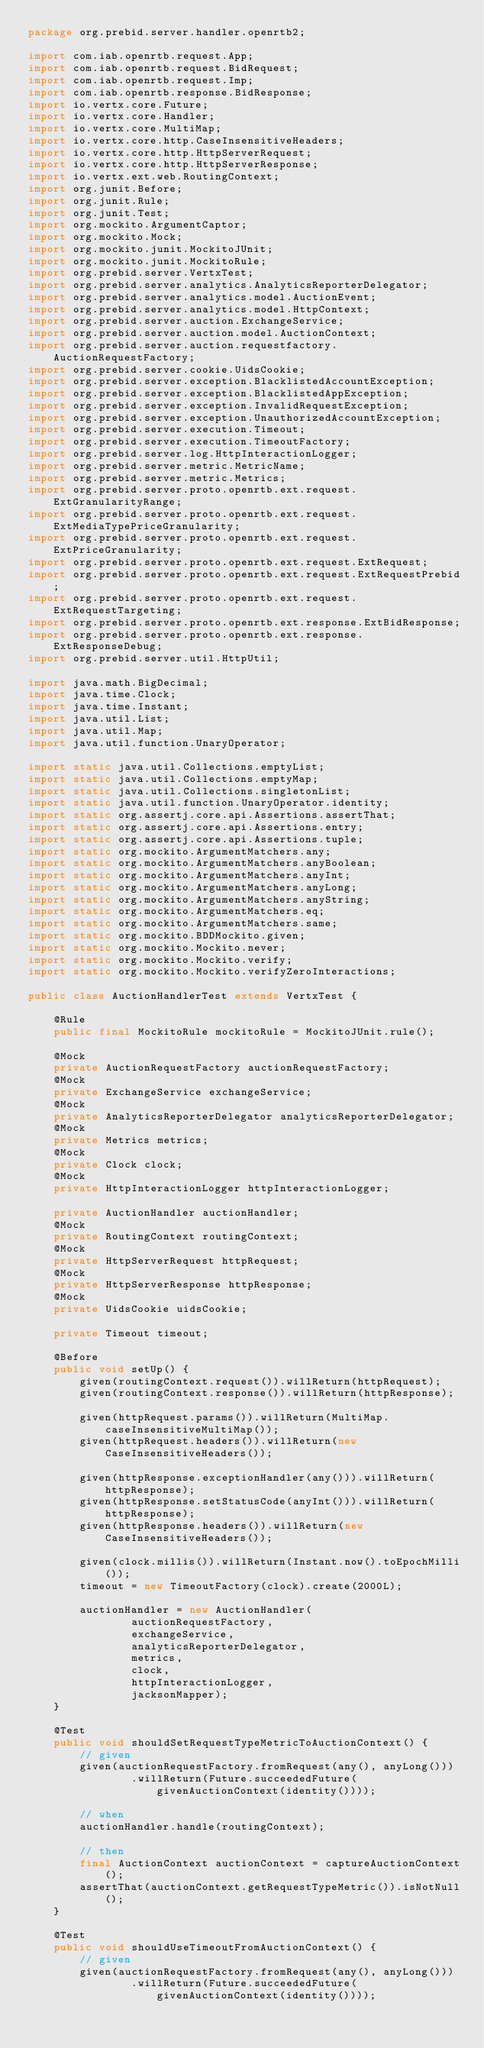Convert code to text. <code><loc_0><loc_0><loc_500><loc_500><_Java_>package org.prebid.server.handler.openrtb2;

import com.iab.openrtb.request.App;
import com.iab.openrtb.request.BidRequest;
import com.iab.openrtb.request.Imp;
import com.iab.openrtb.response.BidResponse;
import io.vertx.core.Future;
import io.vertx.core.Handler;
import io.vertx.core.MultiMap;
import io.vertx.core.http.CaseInsensitiveHeaders;
import io.vertx.core.http.HttpServerRequest;
import io.vertx.core.http.HttpServerResponse;
import io.vertx.ext.web.RoutingContext;
import org.junit.Before;
import org.junit.Rule;
import org.junit.Test;
import org.mockito.ArgumentCaptor;
import org.mockito.Mock;
import org.mockito.junit.MockitoJUnit;
import org.mockito.junit.MockitoRule;
import org.prebid.server.VertxTest;
import org.prebid.server.analytics.AnalyticsReporterDelegator;
import org.prebid.server.analytics.model.AuctionEvent;
import org.prebid.server.analytics.model.HttpContext;
import org.prebid.server.auction.ExchangeService;
import org.prebid.server.auction.model.AuctionContext;
import org.prebid.server.auction.requestfactory.AuctionRequestFactory;
import org.prebid.server.cookie.UidsCookie;
import org.prebid.server.exception.BlacklistedAccountException;
import org.prebid.server.exception.BlacklistedAppException;
import org.prebid.server.exception.InvalidRequestException;
import org.prebid.server.exception.UnauthorizedAccountException;
import org.prebid.server.execution.Timeout;
import org.prebid.server.execution.TimeoutFactory;
import org.prebid.server.log.HttpInteractionLogger;
import org.prebid.server.metric.MetricName;
import org.prebid.server.metric.Metrics;
import org.prebid.server.proto.openrtb.ext.request.ExtGranularityRange;
import org.prebid.server.proto.openrtb.ext.request.ExtMediaTypePriceGranularity;
import org.prebid.server.proto.openrtb.ext.request.ExtPriceGranularity;
import org.prebid.server.proto.openrtb.ext.request.ExtRequest;
import org.prebid.server.proto.openrtb.ext.request.ExtRequestPrebid;
import org.prebid.server.proto.openrtb.ext.request.ExtRequestTargeting;
import org.prebid.server.proto.openrtb.ext.response.ExtBidResponse;
import org.prebid.server.proto.openrtb.ext.response.ExtResponseDebug;
import org.prebid.server.util.HttpUtil;

import java.math.BigDecimal;
import java.time.Clock;
import java.time.Instant;
import java.util.List;
import java.util.Map;
import java.util.function.UnaryOperator;

import static java.util.Collections.emptyList;
import static java.util.Collections.emptyMap;
import static java.util.Collections.singletonList;
import static java.util.function.UnaryOperator.identity;
import static org.assertj.core.api.Assertions.assertThat;
import static org.assertj.core.api.Assertions.entry;
import static org.assertj.core.api.Assertions.tuple;
import static org.mockito.ArgumentMatchers.any;
import static org.mockito.ArgumentMatchers.anyBoolean;
import static org.mockito.ArgumentMatchers.anyInt;
import static org.mockito.ArgumentMatchers.anyLong;
import static org.mockito.ArgumentMatchers.anyString;
import static org.mockito.ArgumentMatchers.eq;
import static org.mockito.ArgumentMatchers.same;
import static org.mockito.BDDMockito.given;
import static org.mockito.Mockito.never;
import static org.mockito.Mockito.verify;
import static org.mockito.Mockito.verifyZeroInteractions;

public class AuctionHandlerTest extends VertxTest {

    @Rule
    public final MockitoRule mockitoRule = MockitoJUnit.rule();

    @Mock
    private AuctionRequestFactory auctionRequestFactory;
    @Mock
    private ExchangeService exchangeService;
    @Mock
    private AnalyticsReporterDelegator analyticsReporterDelegator;
    @Mock
    private Metrics metrics;
    @Mock
    private Clock clock;
    @Mock
    private HttpInteractionLogger httpInteractionLogger;

    private AuctionHandler auctionHandler;
    @Mock
    private RoutingContext routingContext;
    @Mock
    private HttpServerRequest httpRequest;
    @Mock
    private HttpServerResponse httpResponse;
    @Mock
    private UidsCookie uidsCookie;

    private Timeout timeout;

    @Before
    public void setUp() {
        given(routingContext.request()).willReturn(httpRequest);
        given(routingContext.response()).willReturn(httpResponse);

        given(httpRequest.params()).willReturn(MultiMap.caseInsensitiveMultiMap());
        given(httpRequest.headers()).willReturn(new CaseInsensitiveHeaders());

        given(httpResponse.exceptionHandler(any())).willReturn(httpResponse);
        given(httpResponse.setStatusCode(anyInt())).willReturn(httpResponse);
        given(httpResponse.headers()).willReturn(new CaseInsensitiveHeaders());

        given(clock.millis()).willReturn(Instant.now().toEpochMilli());
        timeout = new TimeoutFactory(clock).create(2000L);

        auctionHandler = new AuctionHandler(
                auctionRequestFactory,
                exchangeService,
                analyticsReporterDelegator,
                metrics,
                clock,
                httpInteractionLogger,
                jacksonMapper);
    }

    @Test
    public void shouldSetRequestTypeMetricToAuctionContext() {
        // given
        given(auctionRequestFactory.fromRequest(any(), anyLong()))
                .willReturn(Future.succeededFuture(givenAuctionContext(identity())));

        // when
        auctionHandler.handle(routingContext);

        // then
        final AuctionContext auctionContext = captureAuctionContext();
        assertThat(auctionContext.getRequestTypeMetric()).isNotNull();
    }

    @Test
    public void shouldUseTimeoutFromAuctionContext() {
        // given
        given(auctionRequestFactory.fromRequest(any(), anyLong()))
                .willReturn(Future.succeededFuture(givenAuctionContext(identity())));
</code> 